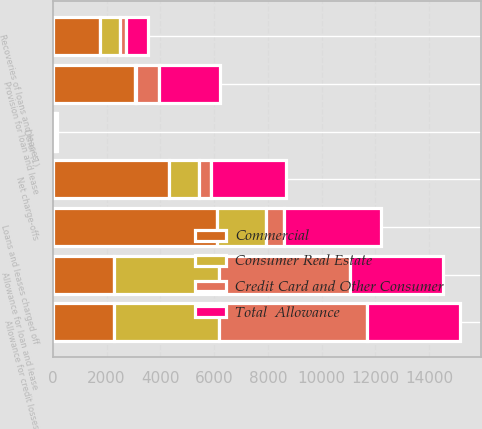Convert chart. <chart><loc_0><loc_0><loc_500><loc_500><stacked_bar_chart><ecel><fcel>Allowance for loan and lease<fcel>Loans and leases charged off<fcel>Recoveries of loans and leases<fcel>Net charge-offs<fcel>Provision for loan and lease<fcel>Other (1)<fcel>Allowance for credit losses<nl><fcel>Consumer Real Estate<fcel>3914<fcel>1841<fcel>732<fcel>1109<fcel>70<fcel>34<fcel>3914<nl><fcel>Total  Allowance<fcel>3471<fcel>3620<fcel>813<fcel>2807<fcel>2278<fcel>47<fcel>3471<nl><fcel>Credit Card and Other Consumer<fcel>4849<fcel>644<fcel>222<fcel>422<fcel>835<fcel>1<fcel>5495<nl><fcel>Commercial<fcel>2278<fcel>6105<fcel>1767<fcel>4338<fcel>3043<fcel>82<fcel>2278<nl></chart> 